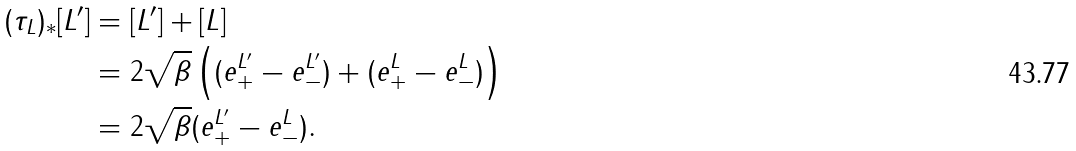<formula> <loc_0><loc_0><loc_500><loc_500>( \tau _ { L } ) _ { \ast } [ L ^ { \prime } ] & = [ L ^ { \prime } ] + [ L ] \\ & = 2 \sqrt { \beta } \left ( ( e ^ { L ^ { \prime } } _ { + } - e ^ { L ^ { \prime } } _ { - } ) + ( e ^ { L } _ { + } - e ^ { L } _ { - } ) \right ) \\ & = 2 \sqrt { \beta } ( e ^ { L ^ { \prime } } _ { + } - e ^ { L } _ { - } ) .</formula> 